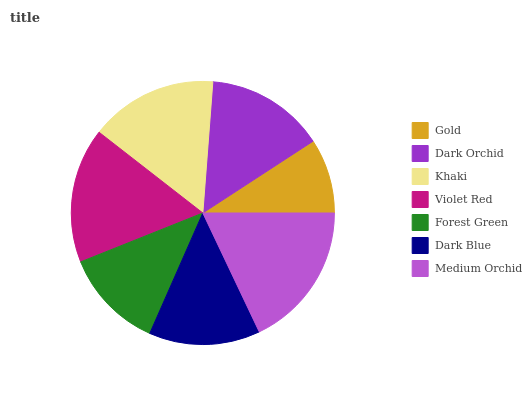Is Gold the minimum?
Answer yes or no. Yes. Is Medium Orchid the maximum?
Answer yes or no. Yes. Is Dark Orchid the minimum?
Answer yes or no. No. Is Dark Orchid the maximum?
Answer yes or no. No. Is Dark Orchid greater than Gold?
Answer yes or no. Yes. Is Gold less than Dark Orchid?
Answer yes or no. Yes. Is Gold greater than Dark Orchid?
Answer yes or no. No. Is Dark Orchid less than Gold?
Answer yes or no. No. Is Dark Orchid the high median?
Answer yes or no. Yes. Is Dark Orchid the low median?
Answer yes or no. Yes. Is Violet Red the high median?
Answer yes or no. No. Is Violet Red the low median?
Answer yes or no. No. 